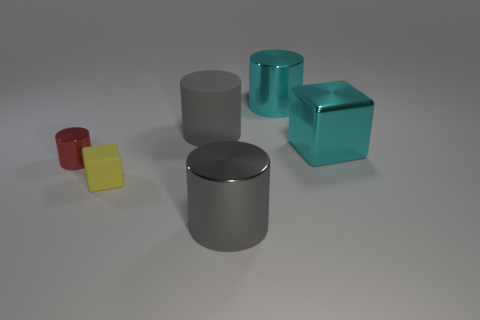There is a large gray cylinder behind the block behind the yellow thing; are there any shiny cylinders that are behind it?
Offer a terse response. Yes. There is a cube that is on the left side of the metallic object right of the metal cylinder that is behind the shiny cube; what color is it?
Make the answer very short. Yellow. There is a large cyan thing that is the same shape as the tiny yellow thing; what is it made of?
Offer a very short reply. Metal. There is a matte object that is behind the metallic object to the right of the cyan cylinder; what size is it?
Your answer should be compact. Large. There is a gray object behind the small yellow object; what is it made of?
Ensure brevity in your answer.  Rubber. What size is the red object that is made of the same material as the cyan block?
Your answer should be compact. Small. How many tiny matte objects have the same shape as the large gray matte object?
Your answer should be very brief. 0. Does the tiny yellow object have the same shape as the large gray thing that is left of the large gray shiny object?
Offer a terse response. No. What shape is the metal object that is the same color as the big rubber cylinder?
Give a very brief answer. Cylinder. Is there a cylinder made of the same material as the tiny yellow object?
Give a very brief answer. Yes. 